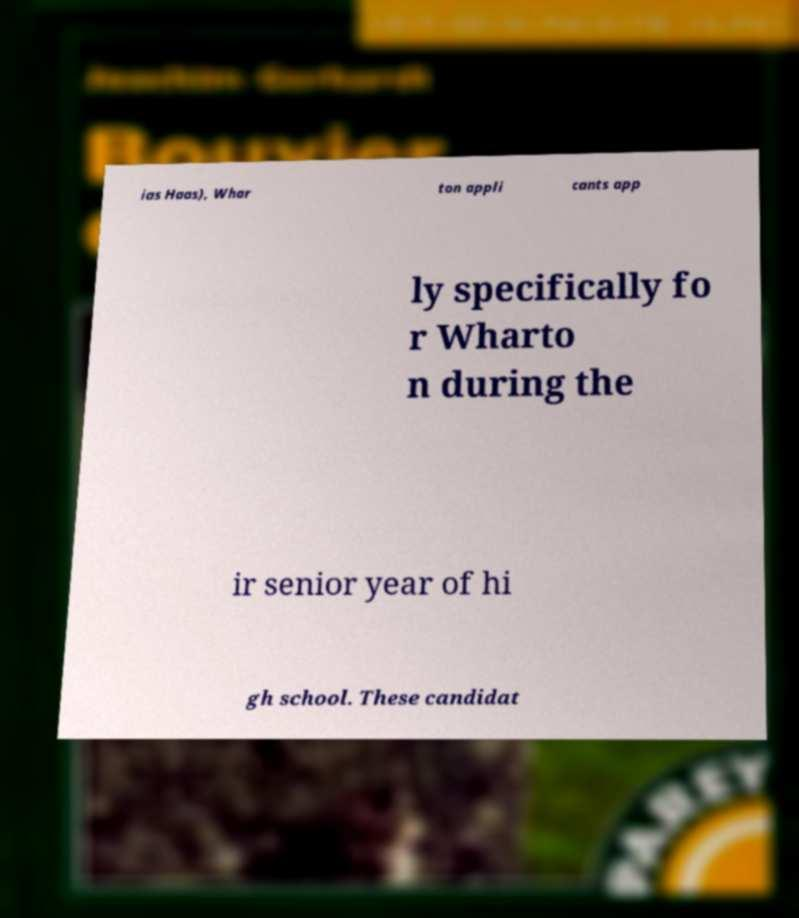For documentation purposes, I need the text within this image transcribed. Could you provide that? ias Haas), Whar ton appli cants app ly specifically fo r Wharto n during the ir senior year of hi gh school. These candidat 